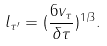<formula> <loc_0><loc_0><loc_500><loc_500>l _ { \tau ^ { \prime } } = ( \frac { 6 v _ { \tau } } { \delta \tau } ) ^ { 1 / 3 } .</formula> 